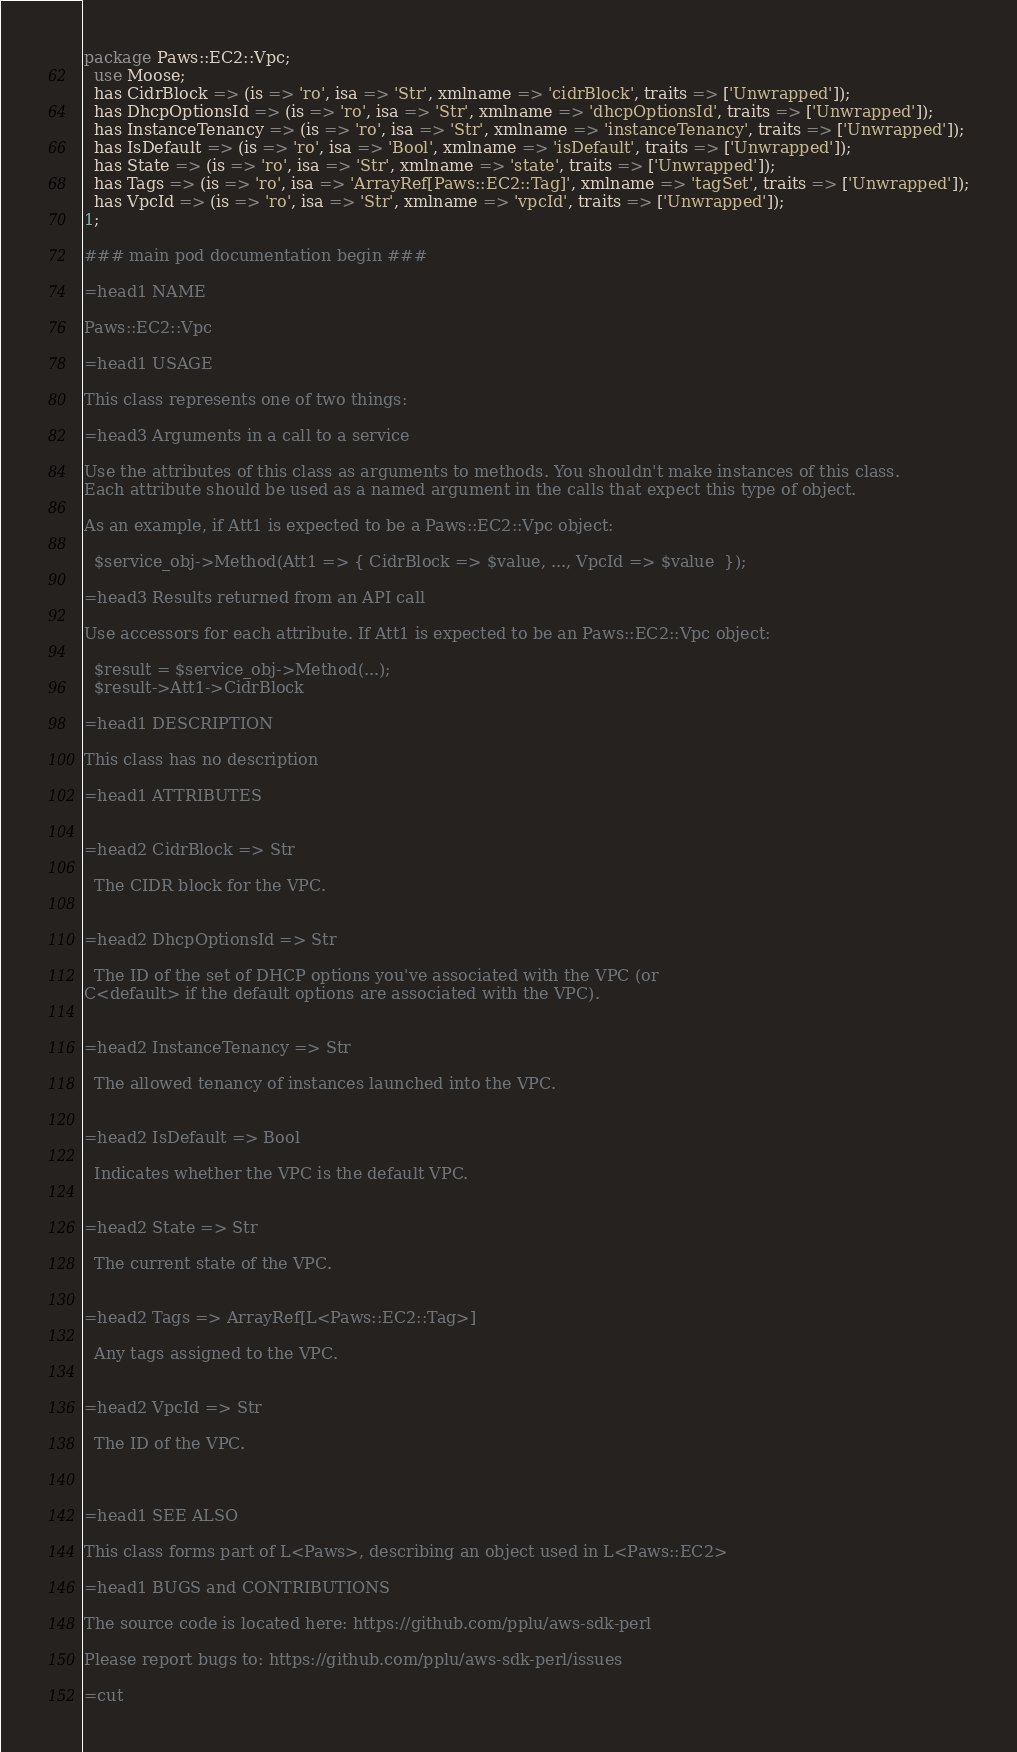<code> <loc_0><loc_0><loc_500><loc_500><_Perl_>package Paws::EC2::Vpc;
  use Moose;
  has CidrBlock => (is => 'ro', isa => 'Str', xmlname => 'cidrBlock', traits => ['Unwrapped']);
  has DhcpOptionsId => (is => 'ro', isa => 'Str', xmlname => 'dhcpOptionsId', traits => ['Unwrapped']);
  has InstanceTenancy => (is => 'ro', isa => 'Str', xmlname => 'instanceTenancy', traits => ['Unwrapped']);
  has IsDefault => (is => 'ro', isa => 'Bool', xmlname => 'isDefault', traits => ['Unwrapped']);
  has State => (is => 'ro', isa => 'Str', xmlname => 'state', traits => ['Unwrapped']);
  has Tags => (is => 'ro', isa => 'ArrayRef[Paws::EC2::Tag]', xmlname => 'tagSet', traits => ['Unwrapped']);
  has VpcId => (is => 'ro', isa => 'Str', xmlname => 'vpcId', traits => ['Unwrapped']);
1;

### main pod documentation begin ###

=head1 NAME

Paws::EC2::Vpc

=head1 USAGE

This class represents one of two things:

=head3 Arguments in a call to a service

Use the attributes of this class as arguments to methods. You shouldn't make instances of this class. 
Each attribute should be used as a named argument in the calls that expect this type of object.

As an example, if Att1 is expected to be a Paws::EC2::Vpc object:

  $service_obj->Method(Att1 => { CidrBlock => $value, ..., VpcId => $value  });

=head3 Results returned from an API call

Use accessors for each attribute. If Att1 is expected to be an Paws::EC2::Vpc object:

  $result = $service_obj->Method(...);
  $result->Att1->CidrBlock

=head1 DESCRIPTION

This class has no description

=head1 ATTRIBUTES


=head2 CidrBlock => Str

  The CIDR block for the VPC.


=head2 DhcpOptionsId => Str

  The ID of the set of DHCP options you've associated with the VPC (or
C<default> if the default options are associated with the VPC).


=head2 InstanceTenancy => Str

  The allowed tenancy of instances launched into the VPC.


=head2 IsDefault => Bool

  Indicates whether the VPC is the default VPC.


=head2 State => Str

  The current state of the VPC.


=head2 Tags => ArrayRef[L<Paws::EC2::Tag>]

  Any tags assigned to the VPC.


=head2 VpcId => Str

  The ID of the VPC.



=head1 SEE ALSO

This class forms part of L<Paws>, describing an object used in L<Paws::EC2>

=head1 BUGS and CONTRIBUTIONS

The source code is located here: https://github.com/pplu/aws-sdk-perl

Please report bugs to: https://github.com/pplu/aws-sdk-perl/issues

=cut
</code> 